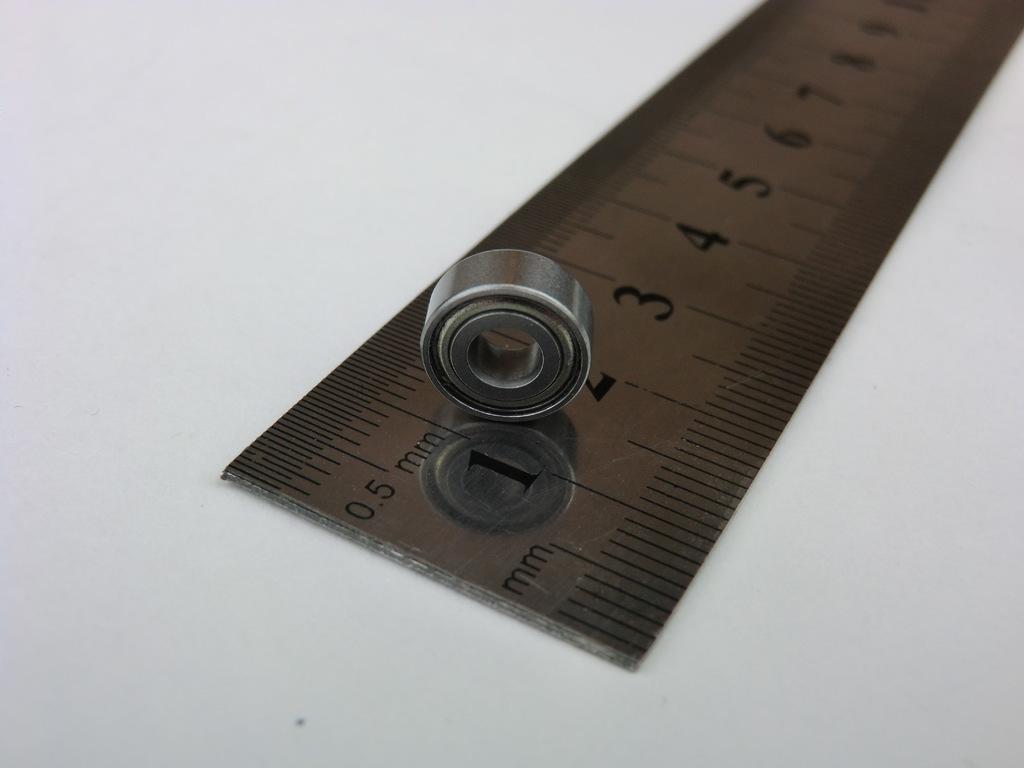What units is this portion of the ruler in?
Provide a succinct answer. Mm. 